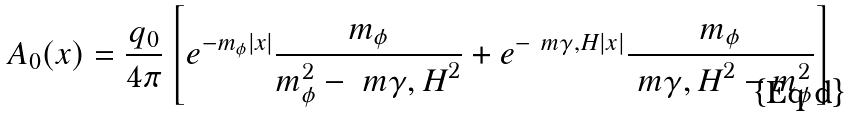<formula> <loc_0><loc_0><loc_500><loc_500>A _ { 0 } ( x ) = \frac { q _ { 0 } } { 4 \pi } \left [ e ^ { - m _ { \phi } | x | } \frac { m _ { \phi } } { m _ { \phi } ^ { 2 } - \ m { \gamma , H } ^ { 2 } } + e ^ { - \ m { \gamma , H } | x | } \frac { m _ { \phi } } { \ m { \gamma , H } ^ { 2 } - m _ { \phi } ^ { 2 } } \right ]</formula> 